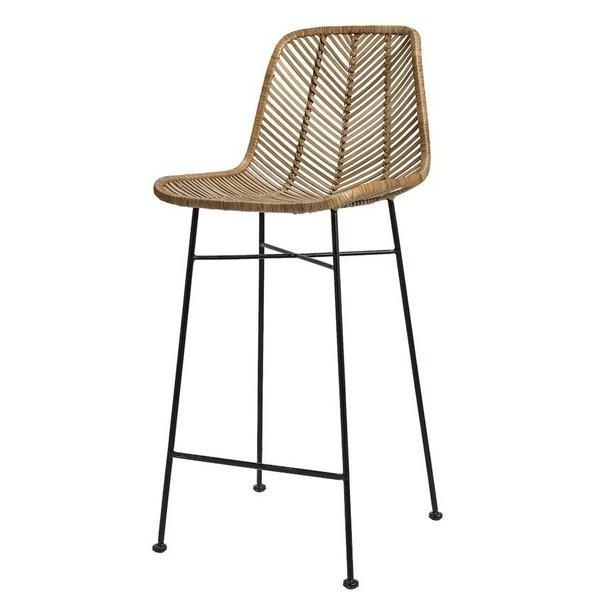Imagine this bar stool in an outdoor setting. How would it hold up, and what maintenance might it require? In an outdoor setting, this bar stool could make a stylish addition to a patio or garden area. However, the natural rattan material might be vulnerable to the elements, such as rain, direct sunlight, and fluctuating temperatures. To ensure that the stool holds up well outside, it would require some maintenance. This could include regular cleaning to remove dust and debris, as well as protecting it from excessive moisture by moving it under cover during wet weather. Applying a protective coating or varnish could help preserve the rattan and prevent it from becoming brittle or discolored due to UV exposure. Additionally, periodic inspections for damage or signs of wear would be necessary to extend the stool's longevity. 